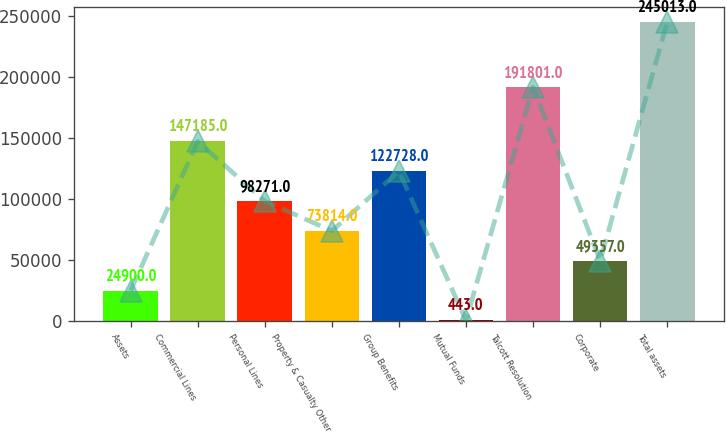Convert chart. <chart><loc_0><loc_0><loc_500><loc_500><bar_chart><fcel>Assets<fcel>Commercial Lines<fcel>Personal Lines<fcel>Property & Casualty Other<fcel>Group Benefits<fcel>Mutual Funds<fcel>Talcott Resolution<fcel>Corporate<fcel>Total assets<nl><fcel>24900<fcel>147185<fcel>98271<fcel>73814<fcel>122728<fcel>443<fcel>191801<fcel>49357<fcel>245013<nl></chart> 